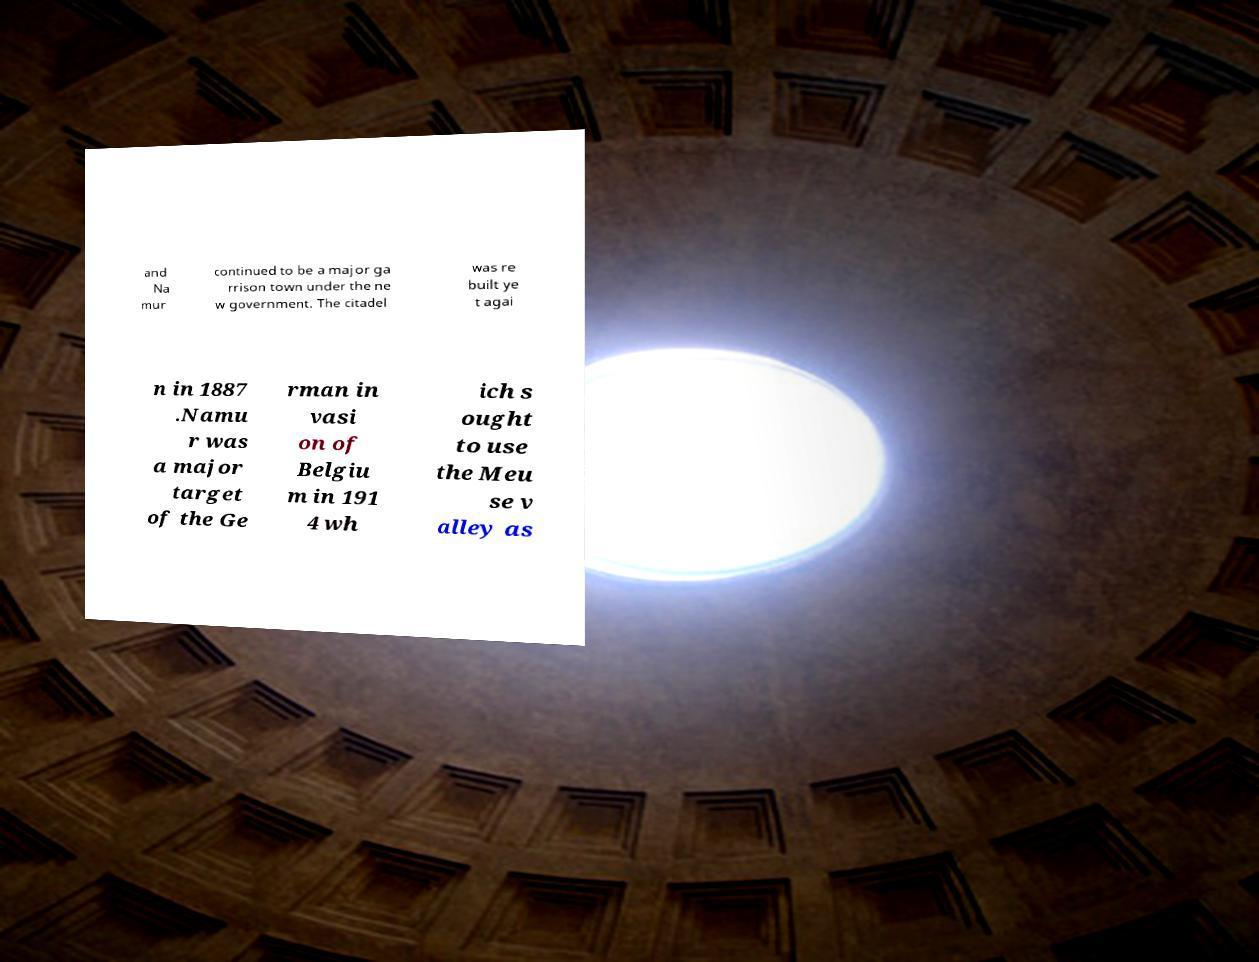There's text embedded in this image that I need extracted. Can you transcribe it verbatim? and Na mur continued to be a major ga rrison town under the ne w government. The citadel was re built ye t agai n in 1887 .Namu r was a major target of the Ge rman in vasi on of Belgiu m in 191 4 wh ich s ought to use the Meu se v alley as 